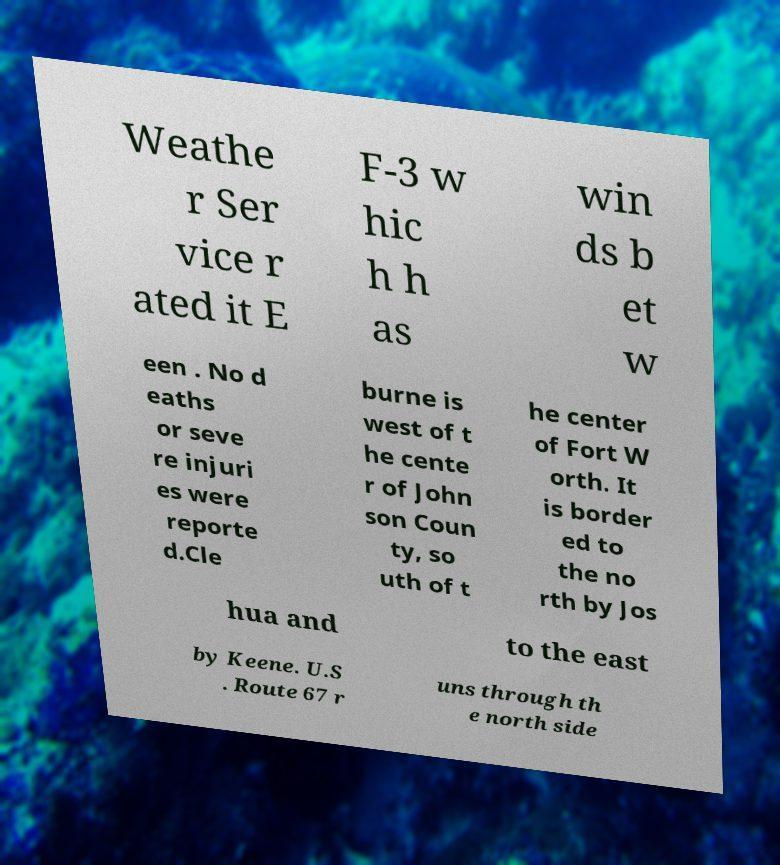Can you read and provide the text displayed in the image?This photo seems to have some interesting text. Can you extract and type it out for me? Weathe r Ser vice r ated it E F-3 w hic h h as win ds b et w een . No d eaths or seve re injuri es were reporte d.Cle burne is west of t he cente r of John son Coun ty, so uth of t he center of Fort W orth. It is border ed to the no rth by Jos hua and to the east by Keene. U.S . Route 67 r uns through th e north side 